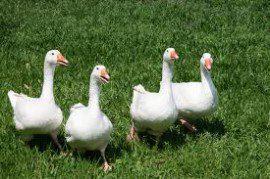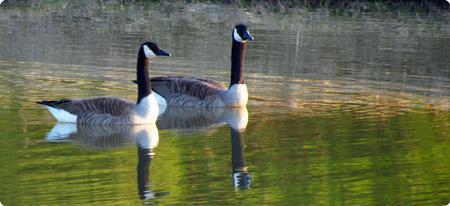The first image is the image on the left, the second image is the image on the right. Examine the images to the left and right. Is the description "The left image shows fowl standing on grass." accurate? Answer yes or no. Yes. 